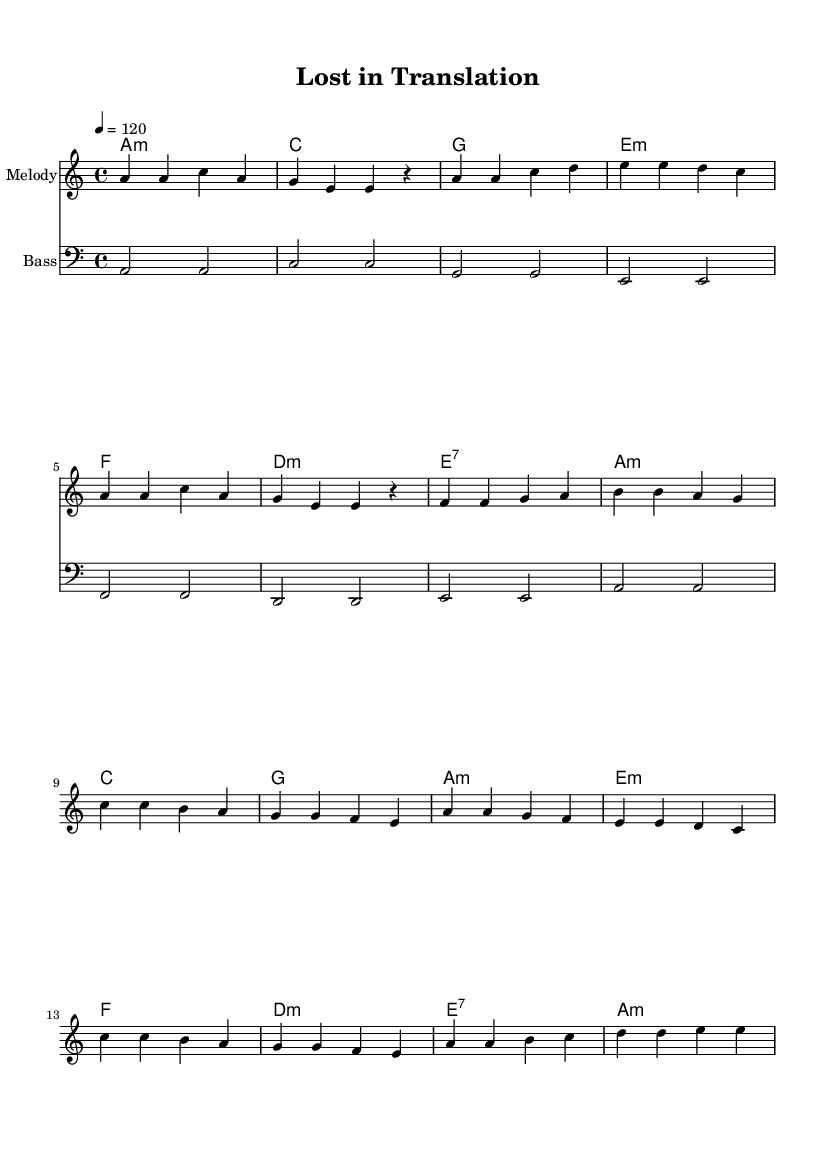What is the key signature of this music? The key signature is A minor, which has no sharps or flats.
Answer: A minor What is the time signature of this music? The time signature is indicated as 4/4, meaning there are four beats in a measure and the quarter note gets one beat.
Answer: 4/4 What is the tempo marking for this music? The tempo marking is 120 beats per minute, suggesting a moderately fast pace for the music.
Answer: 120 How many measures are in the verse section? The verse section consists of 8 measures, as indicated by the grouping of notes in that part of the score.
Answer: 8 Which chord is used in the first measure of the chorus? The first measure of the chorus has a C major chord, noted in the chord names above the staff.
Answer: C What kind of rhythm is predominantly used in the melody? The rhythm in the melody is primarily based on quarter notes and eighth notes, creating a danceable, syncopated feel typical in disco music.
Answer: Quarter and eighth notes How does the bass line complement the harmony? The bass line outlines the roots of the chords in harmony, reinforcing the harmonic structure and creating a solid foundation for the song.
Answer: Reinforces roots of chords 